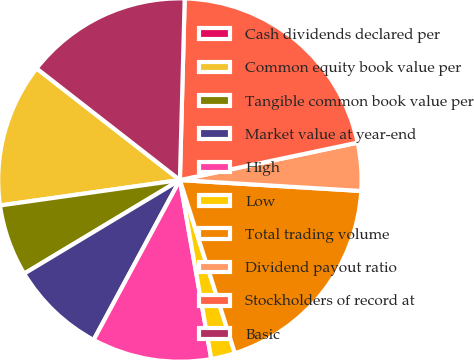<chart> <loc_0><loc_0><loc_500><loc_500><pie_chart><fcel>Cash dividends declared per<fcel>Common equity book value per<fcel>Tangible common book value per<fcel>Market value at year-end<fcel>High<fcel>Low<fcel>Total trading volume<fcel>Dividend payout ratio<fcel>Stockholders of record at<fcel>Basic<nl><fcel>0.0%<fcel>12.77%<fcel>6.38%<fcel>8.51%<fcel>10.64%<fcel>2.13%<fcel>19.15%<fcel>4.26%<fcel>21.28%<fcel>14.89%<nl></chart> 